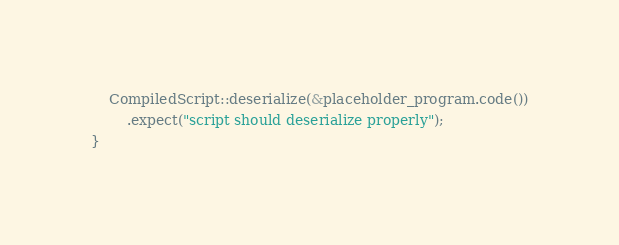<code> <loc_0><loc_0><loc_500><loc_500><_Rust_>    CompiledScript::deserialize(&placeholder_program.code())
        .expect("script should deserialize properly");
}
</code> 